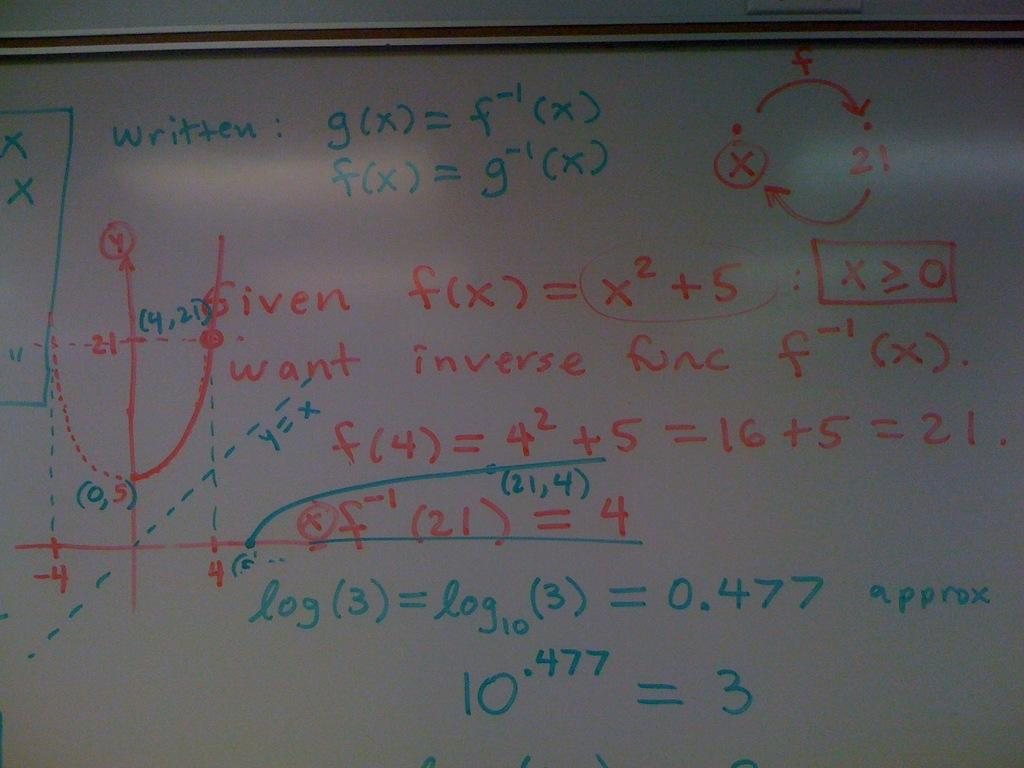<image>
Provide a brief description of the given image. given f(x) = x2 + 5 is written on a board of math equations 